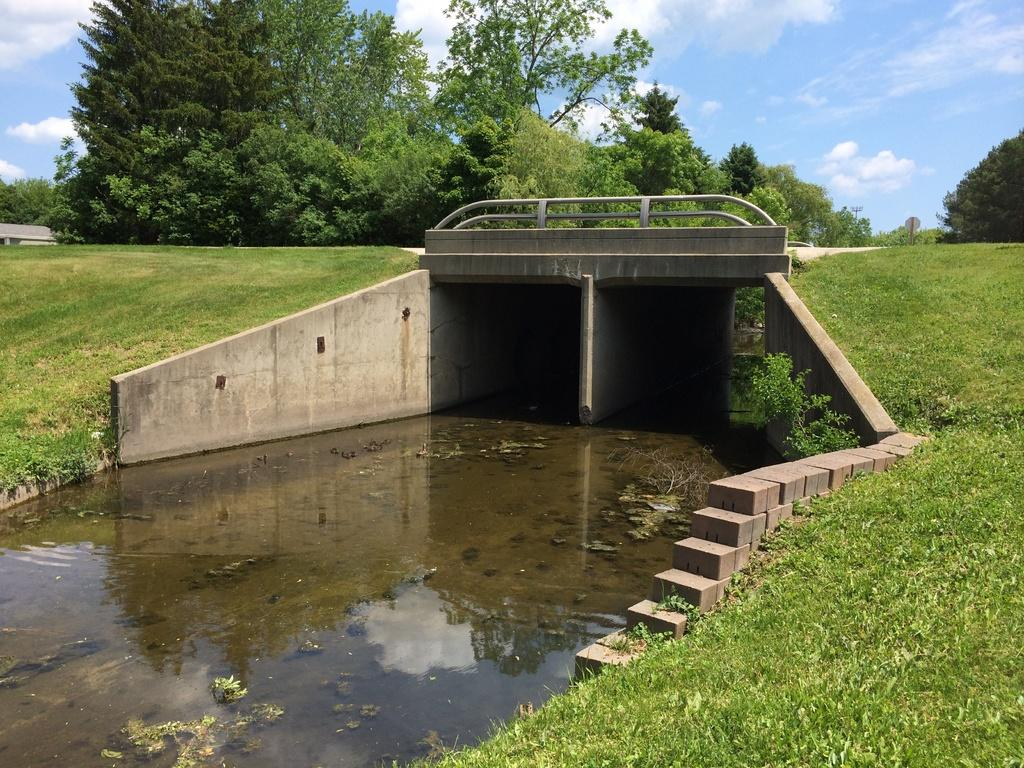What type of structure is present in the image? There is a concrete bridge in the image. What natural element can be seen near the bridge? There is water visible in the image. What type of vegetation is present in the image? There is grass and trees in the image. What is visible at the top of the image? The sky is visible at the top of the image, and clouds are present in the sky. Can you see a map and quill being used by someone on the bridge in the image? No, there is no map or quill visible in the image, and no one is shown using them on the bridge. 